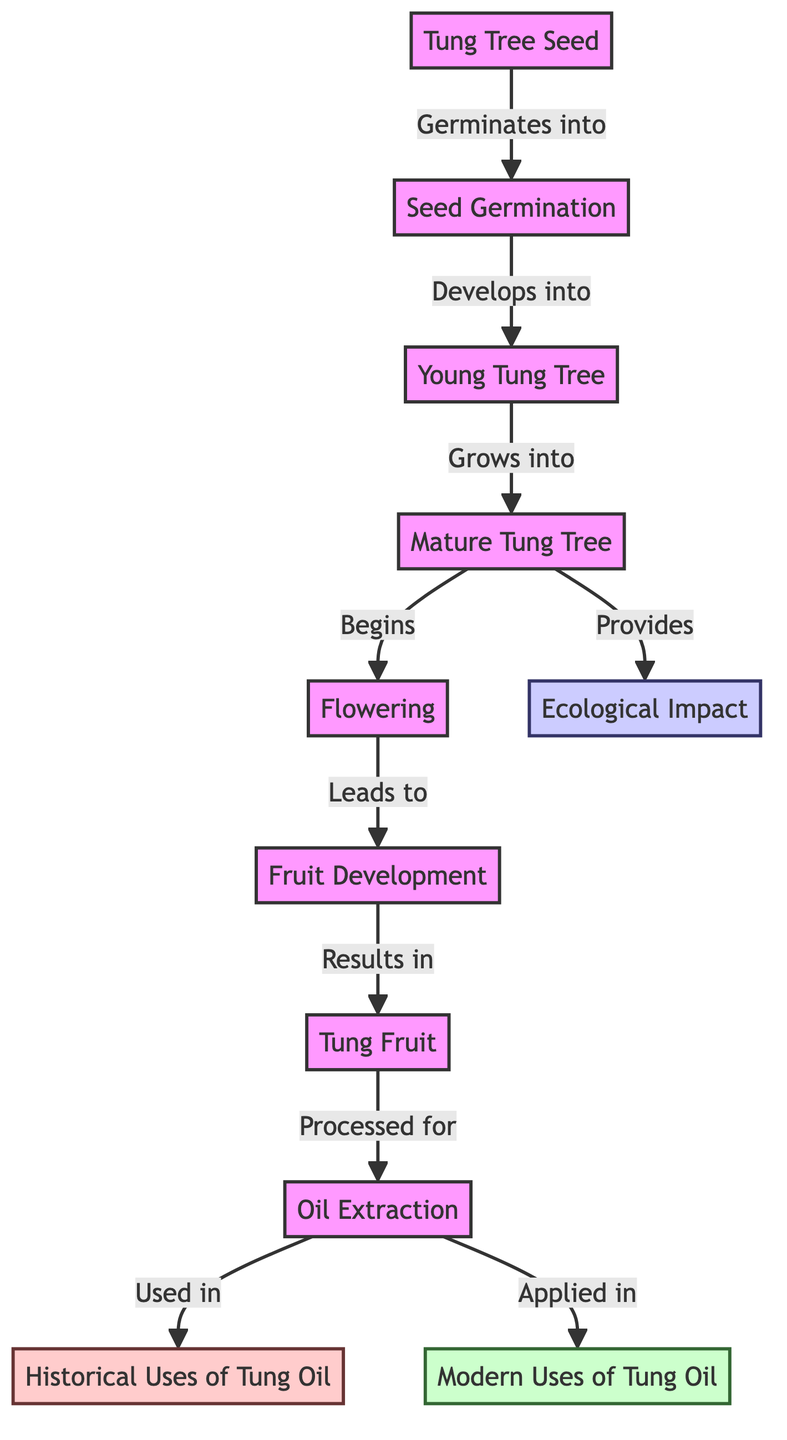What is the first stage in the lifecycle of the Tung tree? The diagram indicates that the first stage is represented by the node "Tung Tree Seed," which germinates into the next stage.
Answer: Tung Tree Seed What process follows the "Mature Tung Tree" stage? The diagram shows that after reaching the "Mature Tung Tree" stage, it begins "Flowering," which is the next step in the lifecycle.
Answer: Flowering How many nodes illustrate the oil extraction process? The diagram indicates that there is one node dedicated to "Oil Extraction," which is the stage where Tung fruit is processed.
Answer: 1 What are two applications of Tung oil shown in the diagram? According to the diagram, Tung oil has two usage nodes: "Historical Uses of Tung Oil" and "Modern Uses of Tung Oil," which are both linked from the oil extraction stage.
Answer: Historical Uses of Tung Oil, Modern Uses of Tung Oil What ecological contribution does the "Mature Tung Tree" provide? The diagram shows that the "Mature Tung Tree" provides an "Ecological Impact," indicating its role in the environment.
Answer: Ecological Impact What is the relationship between "Tung Fruit" and oil extraction? The diagram illustrates that "Tung Fruit" is a result of earlier stages and leads directly to "Oil Extraction," establishing a direct processing relationship.
Answer: Processed for What stage comes immediately after "Fruit Development"? The next stage after "Fruit Development," as indicated by the diagram's flow, is "Tung Fruit." This shows the direct progression in the lifecycle.
Answer: Tung Fruit How many stages are there from seed to oil extraction? Counting all the stages from "Tung Tree Seed" to "Oil Extraction" as shown, there are eight stages in total leading up to oil extraction.
Answer: 8 Which two colors represent the historical and modern uses of Tung oil in the diagram? The historical uses are shown in a light red color, while modern uses are represented in green, as per the class definitions in the diagram.
Answer: Light red, Green 